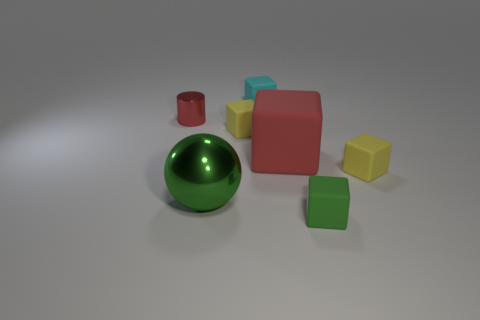Subtract all green cylinders. Subtract all yellow balls. How many cylinders are left? 1 Add 2 red matte blocks. How many objects exist? 9 Subtract all cubes. How many objects are left? 2 Add 1 red metallic objects. How many red metallic objects are left? 2 Add 3 small yellow matte objects. How many small yellow matte objects exist? 5 Subtract 0 brown cylinders. How many objects are left? 7 Subtract all tiny cyan matte cubes. Subtract all big spheres. How many objects are left? 5 